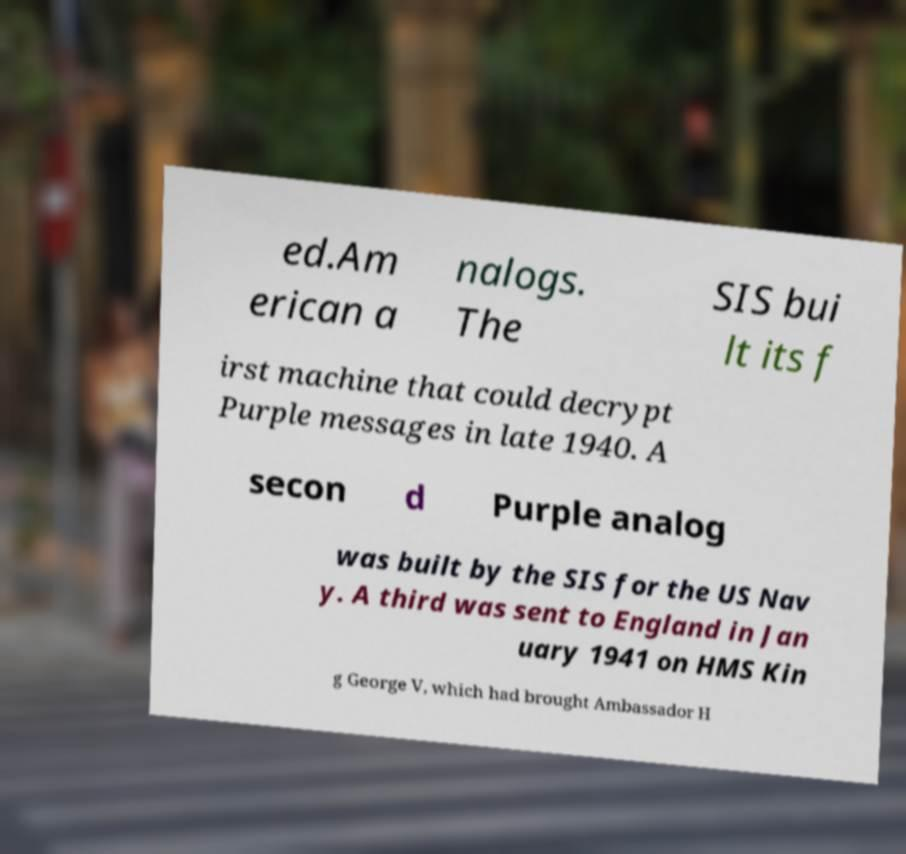Could you assist in decoding the text presented in this image and type it out clearly? ed.Am erican a nalogs. The SIS bui lt its f irst machine that could decrypt Purple messages in late 1940. A secon d Purple analog was built by the SIS for the US Nav y. A third was sent to England in Jan uary 1941 on HMS Kin g George V, which had brought Ambassador H 